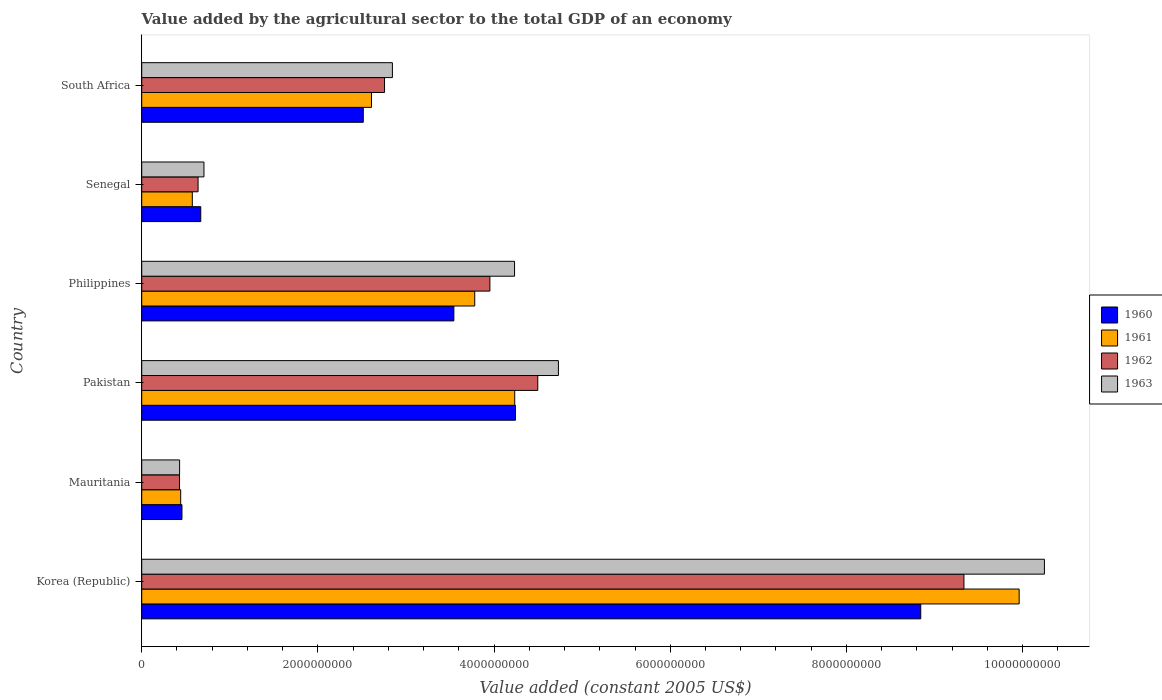Are the number of bars on each tick of the Y-axis equal?
Your response must be concise. Yes. What is the label of the 2nd group of bars from the top?
Your response must be concise. Senegal. In how many cases, is the number of bars for a given country not equal to the number of legend labels?
Keep it short and to the point. 0. What is the value added by the agricultural sector in 1960 in Pakistan?
Keep it short and to the point. 4.24e+09. Across all countries, what is the maximum value added by the agricultural sector in 1962?
Your response must be concise. 9.33e+09. Across all countries, what is the minimum value added by the agricultural sector in 1960?
Give a very brief answer. 4.57e+08. In which country was the value added by the agricultural sector in 1962 minimum?
Make the answer very short. Mauritania. What is the total value added by the agricultural sector in 1962 in the graph?
Give a very brief answer. 2.16e+1. What is the difference between the value added by the agricultural sector in 1963 in Korea (Republic) and that in Pakistan?
Give a very brief answer. 5.52e+09. What is the difference between the value added by the agricultural sector in 1960 in South Africa and the value added by the agricultural sector in 1962 in Pakistan?
Provide a short and direct response. -1.98e+09. What is the average value added by the agricultural sector in 1963 per country?
Provide a succinct answer. 3.87e+09. What is the difference between the value added by the agricultural sector in 1960 and value added by the agricultural sector in 1963 in Korea (Republic)?
Your answer should be compact. -1.40e+09. In how many countries, is the value added by the agricultural sector in 1961 greater than 400000000 US$?
Offer a terse response. 6. What is the ratio of the value added by the agricultural sector in 1961 in Korea (Republic) to that in Mauritania?
Give a very brief answer. 22.52. Is the value added by the agricultural sector in 1960 in Senegal less than that in South Africa?
Keep it short and to the point. Yes. What is the difference between the highest and the second highest value added by the agricultural sector in 1963?
Keep it short and to the point. 5.52e+09. What is the difference between the highest and the lowest value added by the agricultural sector in 1963?
Keep it short and to the point. 9.82e+09. In how many countries, is the value added by the agricultural sector in 1962 greater than the average value added by the agricultural sector in 1962 taken over all countries?
Offer a very short reply. 3. Is the sum of the value added by the agricultural sector in 1961 in Mauritania and South Africa greater than the maximum value added by the agricultural sector in 1963 across all countries?
Your answer should be compact. No. What does the 3rd bar from the top in South Africa represents?
Ensure brevity in your answer.  1961. Are the values on the major ticks of X-axis written in scientific E-notation?
Offer a terse response. No. Does the graph contain grids?
Your response must be concise. No. How many legend labels are there?
Your answer should be very brief. 4. What is the title of the graph?
Your response must be concise. Value added by the agricultural sector to the total GDP of an economy. What is the label or title of the X-axis?
Your answer should be very brief. Value added (constant 2005 US$). What is the label or title of the Y-axis?
Keep it short and to the point. Country. What is the Value added (constant 2005 US$) in 1960 in Korea (Republic)?
Make the answer very short. 8.84e+09. What is the Value added (constant 2005 US$) of 1961 in Korea (Republic)?
Provide a succinct answer. 9.96e+09. What is the Value added (constant 2005 US$) of 1962 in Korea (Republic)?
Your response must be concise. 9.33e+09. What is the Value added (constant 2005 US$) of 1963 in Korea (Republic)?
Provide a short and direct response. 1.02e+1. What is the Value added (constant 2005 US$) in 1960 in Mauritania?
Ensure brevity in your answer.  4.57e+08. What is the Value added (constant 2005 US$) in 1961 in Mauritania?
Provide a short and direct response. 4.42e+08. What is the Value added (constant 2005 US$) of 1962 in Mauritania?
Your answer should be very brief. 4.29e+08. What is the Value added (constant 2005 US$) in 1963 in Mauritania?
Offer a terse response. 4.30e+08. What is the Value added (constant 2005 US$) of 1960 in Pakistan?
Provide a succinct answer. 4.24e+09. What is the Value added (constant 2005 US$) in 1961 in Pakistan?
Ensure brevity in your answer.  4.23e+09. What is the Value added (constant 2005 US$) of 1962 in Pakistan?
Your answer should be very brief. 4.50e+09. What is the Value added (constant 2005 US$) of 1963 in Pakistan?
Offer a very short reply. 4.73e+09. What is the Value added (constant 2005 US$) in 1960 in Philippines?
Ensure brevity in your answer.  3.54e+09. What is the Value added (constant 2005 US$) in 1961 in Philippines?
Offer a very short reply. 3.78e+09. What is the Value added (constant 2005 US$) of 1962 in Philippines?
Your answer should be compact. 3.95e+09. What is the Value added (constant 2005 US$) of 1963 in Philippines?
Your answer should be very brief. 4.23e+09. What is the Value added (constant 2005 US$) of 1960 in Senegal?
Ensure brevity in your answer.  6.70e+08. What is the Value added (constant 2005 US$) in 1961 in Senegal?
Your answer should be very brief. 5.74e+08. What is the Value added (constant 2005 US$) in 1962 in Senegal?
Your response must be concise. 6.40e+08. What is the Value added (constant 2005 US$) in 1963 in Senegal?
Keep it short and to the point. 7.06e+08. What is the Value added (constant 2005 US$) of 1960 in South Africa?
Your answer should be very brief. 2.52e+09. What is the Value added (constant 2005 US$) of 1961 in South Africa?
Make the answer very short. 2.61e+09. What is the Value added (constant 2005 US$) in 1962 in South Africa?
Give a very brief answer. 2.76e+09. What is the Value added (constant 2005 US$) of 1963 in South Africa?
Your answer should be compact. 2.85e+09. Across all countries, what is the maximum Value added (constant 2005 US$) in 1960?
Ensure brevity in your answer.  8.84e+09. Across all countries, what is the maximum Value added (constant 2005 US$) of 1961?
Your response must be concise. 9.96e+09. Across all countries, what is the maximum Value added (constant 2005 US$) of 1962?
Your answer should be compact. 9.33e+09. Across all countries, what is the maximum Value added (constant 2005 US$) in 1963?
Offer a very short reply. 1.02e+1. Across all countries, what is the minimum Value added (constant 2005 US$) of 1960?
Provide a short and direct response. 4.57e+08. Across all countries, what is the minimum Value added (constant 2005 US$) of 1961?
Give a very brief answer. 4.42e+08. Across all countries, what is the minimum Value added (constant 2005 US$) in 1962?
Your response must be concise. 4.29e+08. Across all countries, what is the minimum Value added (constant 2005 US$) in 1963?
Offer a very short reply. 4.30e+08. What is the total Value added (constant 2005 US$) of 1960 in the graph?
Make the answer very short. 2.03e+1. What is the total Value added (constant 2005 US$) in 1961 in the graph?
Ensure brevity in your answer.  2.16e+1. What is the total Value added (constant 2005 US$) of 1962 in the graph?
Make the answer very short. 2.16e+1. What is the total Value added (constant 2005 US$) in 1963 in the graph?
Your answer should be compact. 2.32e+1. What is the difference between the Value added (constant 2005 US$) of 1960 in Korea (Republic) and that in Mauritania?
Give a very brief answer. 8.39e+09. What is the difference between the Value added (constant 2005 US$) in 1961 in Korea (Republic) and that in Mauritania?
Make the answer very short. 9.52e+09. What is the difference between the Value added (constant 2005 US$) of 1962 in Korea (Republic) and that in Mauritania?
Make the answer very short. 8.91e+09. What is the difference between the Value added (constant 2005 US$) of 1963 in Korea (Republic) and that in Mauritania?
Make the answer very short. 9.82e+09. What is the difference between the Value added (constant 2005 US$) in 1960 in Korea (Republic) and that in Pakistan?
Provide a succinct answer. 4.60e+09. What is the difference between the Value added (constant 2005 US$) of 1961 in Korea (Republic) and that in Pakistan?
Provide a short and direct response. 5.73e+09. What is the difference between the Value added (constant 2005 US$) of 1962 in Korea (Republic) and that in Pakistan?
Your answer should be very brief. 4.84e+09. What is the difference between the Value added (constant 2005 US$) of 1963 in Korea (Republic) and that in Pakistan?
Ensure brevity in your answer.  5.52e+09. What is the difference between the Value added (constant 2005 US$) in 1960 in Korea (Republic) and that in Philippines?
Provide a succinct answer. 5.30e+09. What is the difference between the Value added (constant 2005 US$) in 1961 in Korea (Republic) and that in Philippines?
Your response must be concise. 6.18e+09. What is the difference between the Value added (constant 2005 US$) of 1962 in Korea (Republic) and that in Philippines?
Provide a succinct answer. 5.38e+09. What is the difference between the Value added (constant 2005 US$) in 1963 in Korea (Republic) and that in Philippines?
Make the answer very short. 6.02e+09. What is the difference between the Value added (constant 2005 US$) of 1960 in Korea (Republic) and that in Senegal?
Offer a terse response. 8.17e+09. What is the difference between the Value added (constant 2005 US$) of 1961 in Korea (Republic) and that in Senegal?
Make the answer very short. 9.39e+09. What is the difference between the Value added (constant 2005 US$) of 1962 in Korea (Republic) and that in Senegal?
Your response must be concise. 8.69e+09. What is the difference between the Value added (constant 2005 US$) in 1963 in Korea (Republic) and that in Senegal?
Provide a succinct answer. 9.54e+09. What is the difference between the Value added (constant 2005 US$) of 1960 in Korea (Republic) and that in South Africa?
Provide a succinct answer. 6.33e+09. What is the difference between the Value added (constant 2005 US$) in 1961 in Korea (Republic) and that in South Africa?
Your answer should be compact. 7.35e+09. What is the difference between the Value added (constant 2005 US$) in 1962 in Korea (Republic) and that in South Africa?
Your answer should be compact. 6.58e+09. What is the difference between the Value added (constant 2005 US$) of 1963 in Korea (Republic) and that in South Africa?
Your answer should be very brief. 7.40e+09. What is the difference between the Value added (constant 2005 US$) of 1960 in Mauritania and that in Pakistan?
Your answer should be very brief. -3.79e+09. What is the difference between the Value added (constant 2005 US$) of 1961 in Mauritania and that in Pakistan?
Provide a short and direct response. -3.79e+09. What is the difference between the Value added (constant 2005 US$) in 1962 in Mauritania and that in Pakistan?
Keep it short and to the point. -4.07e+09. What is the difference between the Value added (constant 2005 US$) of 1963 in Mauritania and that in Pakistan?
Ensure brevity in your answer.  -4.30e+09. What is the difference between the Value added (constant 2005 US$) of 1960 in Mauritania and that in Philippines?
Give a very brief answer. -3.09e+09. What is the difference between the Value added (constant 2005 US$) in 1961 in Mauritania and that in Philippines?
Offer a terse response. -3.34e+09. What is the difference between the Value added (constant 2005 US$) in 1962 in Mauritania and that in Philippines?
Keep it short and to the point. -3.52e+09. What is the difference between the Value added (constant 2005 US$) in 1963 in Mauritania and that in Philippines?
Offer a very short reply. -3.80e+09. What is the difference between the Value added (constant 2005 US$) of 1960 in Mauritania and that in Senegal?
Offer a very short reply. -2.14e+08. What is the difference between the Value added (constant 2005 US$) of 1961 in Mauritania and that in Senegal?
Provide a succinct answer. -1.32e+08. What is the difference between the Value added (constant 2005 US$) of 1962 in Mauritania and that in Senegal?
Offer a terse response. -2.11e+08. What is the difference between the Value added (constant 2005 US$) of 1963 in Mauritania and that in Senegal?
Make the answer very short. -2.77e+08. What is the difference between the Value added (constant 2005 US$) of 1960 in Mauritania and that in South Africa?
Make the answer very short. -2.06e+09. What is the difference between the Value added (constant 2005 US$) in 1961 in Mauritania and that in South Africa?
Your response must be concise. -2.17e+09. What is the difference between the Value added (constant 2005 US$) of 1962 in Mauritania and that in South Africa?
Keep it short and to the point. -2.33e+09. What is the difference between the Value added (constant 2005 US$) of 1963 in Mauritania and that in South Africa?
Offer a very short reply. -2.42e+09. What is the difference between the Value added (constant 2005 US$) in 1960 in Pakistan and that in Philippines?
Make the answer very short. 7.00e+08. What is the difference between the Value added (constant 2005 US$) in 1961 in Pakistan and that in Philippines?
Give a very brief answer. 4.54e+08. What is the difference between the Value added (constant 2005 US$) of 1962 in Pakistan and that in Philippines?
Your answer should be very brief. 5.44e+08. What is the difference between the Value added (constant 2005 US$) of 1963 in Pakistan and that in Philippines?
Your answer should be very brief. 4.98e+08. What is the difference between the Value added (constant 2005 US$) in 1960 in Pakistan and that in Senegal?
Offer a very short reply. 3.57e+09. What is the difference between the Value added (constant 2005 US$) of 1961 in Pakistan and that in Senegal?
Your answer should be very brief. 3.66e+09. What is the difference between the Value added (constant 2005 US$) of 1962 in Pakistan and that in Senegal?
Your response must be concise. 3.86e+09. What is the difference between the Value added (constant 2005 US$) of 1963 in Pakistan and that in Senegal?
Your answer should be compact. 4.02e+09. What is the difference between the Value added (constant 2005 US$) of 1960 in Pakistan and that in South Africa?
Offer a terse response. 1.73e+09. What is the difference between the Value added (constant 2005 US$) in 1961 in Pakistan and that in South Africa?
Provide a short and direct response. 1.63e+09. What is the difference between the Value added (constant 2005 US$) of 1962 in Pakistan and that in South Africa?
Keep it short and to the point. 1.74e+09. What is the difference between the Value added (constant 2005 US$) of 1963 in Pakistan and that in South Africa?
Offer a terse response. 1.88e+09. What is the difference between the Value added (constant 2005 US$) in 1960 in Philippines and that in Senegal?
Give a very brief answer. 2.87e+09. What is the difference between the Value added (constant 2005 US$) in 1961 in Philippines and that in Senegal?
Make the answer very short. 3.21e+09. What is the difference between the Value added (constant 2005 US$) in 1962 in Philippines and that in Senegal?
Keep it short and to the point. 3.31e+09. What is the difference between the Value added (constant 2005 US$) of 1963 in Philippines and that in Senegal?
Your answer should be compact. 3.53e+09. What is the difference between the Value added (constant 2005 US$) of 1960 in Philippines and that in South Africa?
Your answer should be compact. 1.03e+09. What is the difference between the Value added (constant 2005 US$) in 1961 in Philippines and that in South Africa?
Offer a terse response. 1.17e+09. What is the difference between the Value added (constant 2005 US$) in 1962 in Philippines and that in South Africa?
Give a very brief answer. 1.20e+09. What is the difference between the Value added (constant 2005 US$) of 1963 in Philippines and that in South Africa?
Your response must be concise. 1.39e+09. What is the difference between the Value added (constant 2005 US$) in 1960 in Senegal and that in South Africa?
Your answer should be very brief. -1.84e+09. What is the difference between the Value added (constant 2005 US$) of 1961 in Senegal and that in South Africa?
Keep it short and to the point. -2.03e+09. What is the difference between the Value added (constant 2005 US$) in 1962 in Senegal and that in South Africa?
Ensure brevity in your answer.  -2.12e+09. What is the difference between the Value added (constant 2005 US$) of 1963 in Senegal and that in South Africa?
Offer a very short reply. -2.14e+09. What is the difference between the Value added (constant 2005 US$) in 1960 in Korea (Republic) and the Value added (constant 2005 US$) in 1961 in Mauritania?
Ensure brevity in your answer.  8.40e+09. What is the difference between the Value added (constant 2005 US$) in 1960 in Korea (Republic) and the Value added (constant 2005 US$) in 1962 in Mauritania?
Provide a succinct answer. 8.41e+09. What is the difference between the Value added (constant 2005 US$) of 1960 in Korea (Republic) and the Value added (constant 2005 US$) of 1963 in Mauritania?
Your response must be concise. 8.41e+09. What is the difference between the Value added (constant 2005 US$) in 1961 in Korea (Republic) and the Value added (constant 2005 US$) in 1962 in Mauritania?
Ensure brevity in your answer.  9.53e+09. What is the difference between the Value added (constant 2005 US$) of 1961 in Korea (Republic) and the Value added (constant 2005 US$) of 1963 in Mauritania?
Give a very brief answer. 9.53e+09. What is the difference between the Value added (constant 2005 US$) in 1962 in Korea (Republic) and the Value added (constant 2005 US$) in 1963 in Mauritania?
Give a very brief answer. 8.90e+09. What is the difference between the Value added (constant 2005 US$) of 1960 in Korea (Republic) and the Value added (constant 2005 US$) of 1961 in Pakistan?
Your response must be concise. 4.61e+09. What is the difference between the Value added (constant 2005 US$) of 1960 in Korea (Republic) and the Value added (constant 2005 US$) of 1962 in Pakistan?
Ensure brevity in your answer.  4.35e+09. What is the difference between the Value added (constant 2005 US$) of 1960 in Korea (Republic) and the Value added (constant 2005 US$) of 1963 in Pakistan?
Offer a very short reply. 4.11e+09. What is the difference between the Value added (constant 2005 US$) in 1961 in Korea (Republic) and the Value added (constant 2005 US$) in 1962 in Pakistan?
Provide a succinct answer. 5.46e+09. What is the difference between the Value added (constant 2005 US$) in 1961 in Korea (Republic) and the Value added (constant 2005 US$) in 1963 in Pakistan?
Your answer should be compact. 5.23e+09. What is the difference between the Value added (constant 2005 US$) of 1962 in Korea (Republic) and the Value added (constant 2005 US$) of 1963 in Pakistan?
Ensure brevity in your answer.  4.60e+09. What is the difference between the Value added (constant 2005 US$) in 1960 in Korea (Republic) and the Value added (constant 2005 US$) in 1961 in Philippines?
Make the answer very short. 5.06e+09. What is the difference between the Value added (constant 2005 US$) in 1960 in Korea (Republic) and the Value added (constant 2005 US$) in 1962 in Philippines?
Your answer should be very brief. 4.89e+09. What is the difference between the Value added (constant 2005 US$) of 1960 in Korea (Republic) and the Value added (constant 2005 US$) of 1963 in Philippines?
Offer a very short reply. 4.61e+09. What is the difference between the Value added (constant 2005 US$) of 1961 in Korea (Republic) and the Value added (constant 2005 US$) of 1962 in Philippines?
Offer a terse response. 6.01e+09. What is the difference between the Value added (constant 2005 US$) in 1961 in Korea (Republic) and the Value added (constant 2005 US$) in 1963 in Philippines?
Your response must be concise. 5.73e+09. What is the difference between the Value added (constant 2005 US$) in 1962 in Korea (Republic) and the Value added (constant 2005 US$) in 1963 in Philippines?
Provide a succinct answer. 5.10e+09. What is the difference between the Value added (constant 2005 US$) of 1960 in Korea (Republic) and the Value added (constant 2005 US$) of 1961 in Senegal?
Your answer should be very brief. 8.27e+09. What is the difference between the Value added (constant 2005 US$) of 1960 in Korea (Republic) and the Value added (constant 2005 US$) of 1962 in Senegal?
Keep it short and to the point. 8.20e+09. What is the difference between the Value added (constant 2005 US$) of 1960 in Korea (Republic) and the Value added (constant 2005 US$) of 1963 in Senegal?
Provide a short and direct response. 8.14e+09. What is the difference between the Value added (constant 2005 US$) in 1961 in Korea (Republic) and the Value added (constant 2005 US$) in 1962 in Senegal?
Provide a short and direct response. 9.32e+09. What is the difference between the Value added (constant 2005 US$) in 1961 in Korea (Republic) and the Value added (constant 2005 US$) in 1963 in Senegal?
Your response must be concise. 9.25e+09. What is the difference between the Value added (constant 2005 US$) in 1962 in Korea (Republic) and the Value added (constant 2005 US$) in 1963 in Senegal?
Keep it short and to the point. 8.63e+09. What is the difference between the Value added (constant 2005 US$) of 1960 in Korea (Republic) and the Value added (constant 2005 US$) of 1961 in South Africa?
Provide a short and direct response. 6.24e+09. What is the difference between the Value added (constant 2005 US$) in 1960 in Korea (Republic) and the Value added (constant 2005 US$) in 1962 in South Africa?
Make the answer very short. 6.09e+09. What is the difference between the Value added (constant 2005 US$) of 1960 in Korea (Republic) and the Value added (constant 2005 US$) of 1963 in South Africa?
Keep it short and to the point. 6.00e+09. What is the difference between the Value added (constant 2005 US$) in 1961 in Korea (Republic) and the Value added (constant 2005 US$) in 1962 in South Africa?
Provide a succinct answer. 7.20e+09. What is the difference between the Value added (constant 2005 US$) in 1961 in Korea (Republic) and the Value added (constant 2005 US$) in 1963 in South Africa?
Your answer should be very brief. 7.12e+09. What is the difference between the Value added (constant 2005 US$) in 1962 in Korea (Republic) and the Value added (constant 2005 US$) in 1963 in South Africa?
Ensure brevity in your answer.  6.49e+09. What is the difference between the Value added (constant 2005 US$) of 1960 in Mauritania and the Value added (constant 2005 US$) of 1961 in Pakistan?
Offer a terse response. -3.78e+09. What is the difference between the Value added (constant 2005 US$) in 1960 in Mauritania and the Value added (constant 2005 US$) in 1962 in Pakistan?
Give a very brief answer. -4.04e+09. What is the difference between the Value added (constant 2005 US$) of 1960 in Mauritania and the Value added (constant 2005 US$) of 1963 in Pakistan?
Offer a very short reply. -4.27e+09. What is the difference between the Value added (constant 2005 US$) in 1961 in Mauritania and the Value added (constant 2005 US$) in 1962 in Pakistan?
Your answer should be very brief. -4.05e+09. What is the difference between the Value added (constant 2005 US$) of 1961 in Mauritania and the Value added (constant 2005 US$) of 1963 in Pakistan?
Offer a terse response. -4.29e+09. What is the difference between the Value added (constant 2005 US$) of 1962 in Mauritania and the Value added (constant 2005 US$) of 1963 in Pakistan?
Make the answer very short. -4.30e+09. What is the difference between the Value added (constant 2005 US$) in 1960 in Mauritania and the Value added (constant 2005 US$) in 1961 in Philippines?
Provide a succinct answer. -3.32e+09. What is the difference between the Value added (constant 2005 US$) in 1960 in Mauritania and the Value added (constant 2005 US$) in 1962 in Philippines?
Provide a succinct answer. -3.50e+09. What is the difference between the Value added (constant 2005 US$) in 1960 in Mauritania and the Value added (constant 2005 US$) in 1963 in Philippines?
Keep it short and to the point. -3.78e+09. What is the difference between the Value added (constant 2005 US$) of 1961 in Mauritania and the Value added (constant 2005 US$) of 1962 in Philippines?
Offer a terse response. -3.51e+09. What is the difference between the Value added (constant 2005 US$) of 1961 in Mauritania and the Value added (constant 2005 US$) of 1963 in Philippines?
Your answer should be compact. -3.79e+09. What is the difference between the Value added (constant 2005 US$) of 1962 in Mauritania and the Value added (constant 2005 US$) of 1963 in Philippines?
Give a very brief answer. -3.80e+09. What is the difference between the Value added (constant 2005 US$) of 1960 in Mauritania and the Value added (constant 2005 US$) of 1961 in Senegal?
Your answer should be compact. -1.18e+08. What is the difference between the Value added (constant 2005 US$) in 1960 in Mauritania and the Value added (constant 2005 US$) in 1962 in Senegal?
Provide a succinct answer. -1.83e+08. What is the difference between the Value added (constant 2005 US$) in 1960 in Mauritania and the Value added (constant 2005 US$) in 1963 in Senegal?
Your response must be concise. -2.50e+08. What is the difference between the Value added (constant 2005 US$) of 1961 in Mauritania and the Value added (constant 2005 US$) of 1962 in Senegal?
Your response must be concise. -1.97e+08. What is the difference between the Value added (constant 2005 US$) in 1961 in Mauritania and the Value added (constant 2005 US$) in 1963 in Senegal?
Ensure brevity in your answer.  -2.64e+08. What is the difference between the Value added (constant 2005 US$) of 1962 in Mauritania and the Value added (constant 2005 US$) of 1963 in Senegal?
Give a very brief answer. -2.77e+08. What is the difference between the Value added (constant 2005 US$) of 1960 in Mauritania and the Value added (constant 2005 US$) of 1961 in South Africa?
Ensure brevity in your answer.  -2.15e+09. What is the difference between the Value added (constant 2005 US$) of 1960 in Mauritania and the Value added (constant 2005 US$) of 1962 in South Africa?
Keep it short and to the point. -2.30e+09. What is the difference between the Value added (constant 2005 US$) in 1960 in Mauritania and the Value added (constant 2005 US$) in 1963 in South Africa?
Give a very brief answer. -2.39e+09. What is the difference between the Value added (constant 2005 US$) in 1961 in Mauritania and the Value added (constant 2005 US$) in 1962 in South Africa?
Provide a succinct answer. -2.31e+09. What is the difference between the Value added (constant 2005 US$) of 1961 in Mauritania and the Value added (constant 2005 US$) of 1963 in South Africa?
Offer a very short reply. -2.40e+09. What is the difference between the Value added (constant 2005 US$) of 1962 in Mauritania and the Value added (constant 2005 US$) of 1963 in South Africa?
Provide a succinct answer. -2.42e+09. What is the difference between the Value added (constant 2005 US$) of 1960 in Pakistan and the Value added (constant 2005 US$) of 1961 in Philippines?
Ensure brevity in your answer.  4.62e+08. What is the difference between the Value added (constant 2005 US$) in 1960 in Pakistan and the Value added (constant 2005 US$) in 1962 in Philippines?
Ensure brevity in your answer.  2.90e+08. What is the difference between the Value added (constant 2005 US$) in 1960 in Pakistan and the Value added (constant 2005 US$) in 1963 in Philippines?
Offer a terse response. 1.07e+07. What is the difference between the Value added (constant 2005 US$) of 1961 in Pakistan and the Value added (constant 2005 US$) of 1962 in Philippines?
Offer a very short reply. 2.82e+08. What is the difference between the Value added (constant 2005 US$) in 1961 in Pakistan and the Value added (constant 2005 US$) in 1963 in Philippines?
Ensure brevity in your answer.  2.10e+06. What is the difference between the Value added (constant 2005 US$) of 1962 in Pakistan and the Value added (constant 2005 US$) of 1963 in Philippines?
Offer a terse response. 2.64e+08. What is the difference between the Value added (constant 2005 US$) in 1960 in Pakistan and the Value added (constant 2005 US$) in 1961 in Senegal?
Offer a very short reply. 3.67e+09. What is the difference between the Value added (constant 2005 US$) in 1960 in Pakistan and the Value added (constant 2005 US$) in 1962 in Senegal?
Give a very brief answer. 3.60e+09. What is the difference between the Value added (constant 2005 US$) in 1960 in Pakistan and the Value added (constant 2005 US$) in 1963 in Senegal?
Give a very brief answer. 3.54e+09. What is the difference between the Value added (constant 2005 US$) of 1961 in Pakistan and the Value added (constant 2005 US$) of 1962 in Senegal?
Provide a short and direct response. 3.59e+09. What is the difference between the Value added (constant 2005 US$) in 1961 in Pakistan and the Value added (constant 2005 US$) in 1963 in Senegal?
Offer a terse response. 3.53e+09. What is the difference between the Value added (constant 2005 US$) of 1962 in Pakistan and the Value added (constant 2005 US$) of 1963 in Senegal?
Your answer should be compact. 3.79e+09. What is the difference between the Value added (constant 2005 US$) in 1960 in Pakistan and the Value added (constant 2005 US$) in 1961 in South Africa?
Give a very brief answer. 1.63e+09. What is the difference between the Value added (constant 2005 US$) of 1960 in Pakistan and the Value added (constant 2005 US$) of 1962 in South Africa?
Keep it short and to the point. 1.49e+09. What is the difference between the Value added (constant 2005 US$) of 1960 in Pakistan and the Value added (constant 2005 US$) of 1963 in South Africa?
Offer a terse response. 1.40e+09. What is the difference between the Value added (constant 2005 US$) in 1961 in Pakistan and the Value added (constant 2005 US$) in 1962 in South Africa?
Offer a terse response. 1.48e+09. What is the difference between the Value added (constant 2005 US$) of 1961 in Pakistan and the Value added (constant 2005 US$) of 1963 in South Africa?
Your response must be concise. 1.39e+09. What is the difference between the Value added (constant 2005 US$) in 1962 in Pakistan and the Value added (constant 2005 US$) in 1963 in South Africa?
Your response must be concise. 1.65e+09. What is the difference between the Value added (constant 2005 US$) of 1960 in Philippines and the Value added (constant 2005 US$) of 1961 in Senegal?
Your response must be concise. 2.97e+09. What is the difference between the Value added (constant 2005 US$) of 1960 in Philippines and the Value added (constant 2005 US$) of 1962 in Senegal?
Your answer should be compact. 2.90e+09. What is the difference between the Value added (constant 2005 US$) of 1960 in Philippines and the Value added (constant 2005 US$) of 1963 in Senegal?
Keep it short and to the point. 2.84e+09. What is the difference between the Value added (constant 2005 US$) of 1961 in Philippines and the Value added (constant 2005 US$) of 1962 in Senegal?
Keep it short and to the point. 3.14e+09. What is the difference between the Value added (constant 2005 US$) in 1961 in Philippines and the Value added (constant 2005 US$) in 1963 in Senegal?
Keep it short and to the point. 3.07e+09. What is the difference between the Value added (constant 2005 US$) in 1962 in Philippines and the Value added (constant 2005 US$) in 1963 in Senegal?
Keep it short and to the point. 3.25e+09. What is the difference between the Value added (constant 2005 US$) in 1960 in Philippines and the Value added (constant 2005 US$) in 1961 in South Africa?
Your answer should be very brief. 9.35e+08. What is the difference between the Value added (constant 2005 US$) of 1960 in Philippines and the Value added (constant 2005 US$) of 1962 in South Africa?
Make the answer very short. 7.87e+08. What is the difference between the Value added (constant 2005 US$) of 1960 in Philippines and the Value added (constant 2005 US$) of 1963 in South Africa?
Ensure brevity in your answer.  6.98e+08. What is the difference between the Value added (constant 2005 US$) in 1961 in Philippines and the Value added (constant 2005 US$) in 1962 in South Africa?
Provide a short and direct response. 1.02e+09. What is the difference between the Value added (constant 2005 US$) of 1961 in Philippines and the Value added (constant 2005 US$) of 1963 in South Africa?
Your answer should be compact. 9.35e+08. What is the difference between the Value added (constant 2005 US$) in 1962 in Philippines and the Value added (constant 2005 US$) in 1963 in South Africa?
Your answer should be very brief. 1.11e+09. What is the difference between the Value added (constant 2005 US$) in 1960 in Senegal and the Value added (constant 2005 US$) in 1961 in South Africa?
Provide a short and direct response. -1.94e+09. What is the difference between the Value added (constant 2005 US$) of 1960 in Senegal and the Value added (constant 2005 US$) of 1962 in South Africa?
Offer a terse response. -2.09e+09. What is the difference between the Value added (constant 2005 US$) of 1960 in Senegal and the Value added (constant 2005 US$) of 1963 in South Africa?
Give a very brief answer. -2.18e+09. What is the difference between the Value added (constant 2005 US$) in 1961 in Senegal and the Value added (constant 2005 US$) in 1962 in South Africa?
Offer a very short reply. -2.18e+09. What is the difference between the Value added (constant 2005 US$) in 1961 in Senegal and the Value added (constant 2005 US$) in 1963 in South Africa?
Offer a terse response. -2.27e+09. What is the difference between the Value added (constant 2005 US$) in 1962 in Senegal and the Value added (constant 2005 US$) in 1963 in South Africa?
Your answer should be compact. -2.21e+09. What is the average Value added (constant 2005 US$) in 1960 per country?
Provide a succinct answer. 3.38e+09. What is the average Value added (constant 2005 US$) of 1961 per country?
Your response must be concise. 3.60e+09. What is the average Value added (constant 2005 US$) of 1962 per country?
Your answer should be compact. 3.60e+09. What is the average Value added (constant 2005 US$) of 1963 per country?
Give a very brief answer. 3.87e+09. What is the difference between the Value added (constant 2005 US$) of 1960 and Value added (constant 2005 US$) of 1961 in Korea (Republic)?
Provide a short and direct response. -1.12e+09. What is the difference between the Value added (constant 2005 US$) of 1960 and Value added (constant 2005 US$) of 1962 in Korea (Republic)?
Keep it short and to the point. -4.90e+08. What is the difference between the Value added (constant 2005 US$) of 1960 and Value added (constant 2005 US$) of 1963 in Korea (Republic)?
Your answer should be very brief. -1.40e+09. What is the difference between the Value added (constant 2005 US$) in 1961 and Value added (constant 2005 US$) in 1962 in Korea (Republic)?
Provide a short and direct response. 6.27e+08. What is the difference between the Value added (constant 2005 US$) of 1961 and Value added (constant 2005 US$) of 1963 in Korea (Republic)?
Give a very brief answer. -2.87e+08. What is the difference between the Value added (constant 2005 US$) of 1962 and Value added (constant 2005 US$) of 1963 in Korea (Republic)?
Ensure brevity in your answer.  -9.14e+08. What is the difference between the Value added (constant 2005 US$) of 1960 and Value added (constant 2005 US$) of 1961 in Mauritania?
Offer a very short reply. 1.44e+07. What is the difference between the Value added (constant 2005 US$) in 1960 and Value added (constant 2005 US$) in 1962 in Mauritania?
Ensure brevity in your answer.  2.75e+07. What is the difference between the Value added (constant 2005 US$) in 1960 and Value added (constant 2005 US$) in 1963 in Mauritania?
Your answer should be compact. 2.68e+07. What is the difference between the Value added (constant 2005 US$) of 1961 and Value added (constant 2005 US$) of 1962 in Mauritania?
Provide a succinct answer. 1.31e+07. What is the difference between the Value added (constant 2005 US$) of 1961 and Value added (constant 2005 US$) of 1963 in Mauritania?
Ensure brevity in your answer.  1.24e+07. What is the difference between the Value added (constant 2005 US$) in 1962 and Value added (constant 2005 US$) in 1963 in Mauritania?
Offer a terse response. -7.06e+05. What is the difference between the Value added (constant 2005 US$) in 1960 and Value added (constant 2005 US$) in 1961 in Pakistan?
Make the answer very short. 8.56e+06. What is the difference between the Value added (constant 2005 US$) in 1960 and Value added (constant 2005 US$) in 1962 in Pakistan?
Your answer should be compact. -2.53e+08. What is the difference between the Value added (constant 2005 US$) of 1960 and Value added (constant 2005 US$) of 1963 in Pakistan?
Offer a very short reply. -4.87e+08. What is the difference between the Value added (constant 2005 US$) in 1961 and Value added (constant 2005 US$) in 1962 in Pakistan?
Give a very brief answer. -2.62e+08. What is the difference between the Value added (constant 2005 US$) of 1961 and Value added (constant 2005 US$) of 1963 in Pakistan?
Your answer should be very brief. -4.96e+08. What is the difference between the Value added (constant 2005 US$) of 1962 and Value added (constant 2005 US$) of 1963 in Pakistan?
Provide a short and direct response. -2.34e+08. What is the difference between the Value added (constant 2005 US$) of 1960 and Value added (constant 2005 US$) of 1961 in Philippines?
Your answer should be compact. -2.37e+08. What is the difference between the Value added (constant 2005 US$) of 1960 and Value added (constant 2005 US$) of 1962 in Philippines?
Offer a terse response. -4.09e+08. What is the difference between the Value added (constant 2005 US$) of 1960 and Value added (constant 2005 US$) of 1963 in Philippines?
Your response must be concise. -6.89e+08. What is the difference between the Value added (constant 2005 US$) in 1961 and Value added (constant 2005 US$) in 1962 in Philippines?
Give a very brief answer. -1.72e+08. What is the difference between the Value added (constant 2005 US$) of 1961 and Value added (constant 2005 US$) of 1963 in Philippines?
Your answer should be very brief. -4.52e+08. What is the difference between the Value added (constant 2005 US$) in 1962 and Value added (constant 2005 US$) in 1963 in Philippines?
Your response must be concise. -2.80e+08. What is the difference between the Value added (constant 2005 US$) of 1960 and Value added (constant 2005 US$) of 1961 in Senegal?
Keep it short and to the point. 9.60e+07. What is the difference between the Value added (constant 2005 US$) of 1960 and Value added (constant 2005 US$) of 1962 in Senegal?
Your answer should be very brief. 3.06e+07. What is the difference between the Value added (constant 2005 US$) in 1960 and Value added (constant 2005 US$) in 1963 in Senegal?
Offer a very short reply. -3.60e+07. What is the difference between the Value added (constant 2005 US$) in 1961 and Value added (constant 2005 US$) in 1962 in Senegal?
Your answer should be very brief. -6.53e+07. What is the difference between the Value added (constant 2005 US$) of 1961 and Value added (constant 2005 US$) of 1963 in Senegal?
Your answer should be very brief. -1.32e+08. What is the difference between the Value added (constant 2005 US$) of 1962 and Value added (constant 2005 US$) of 1963 in Senegal?
Provide a succinct answer. -6.67e+07. What is the difference between the Value added (constant 2005 US$) of 1960 and Value added (constant 2005 US$) of 1961 in South Africa?
Give a very brief answer. -9.34e+07. What is the difference between the Value added (constant 2005 US$) in 1960 and Value added (constant 2005 US$) in 1962 in South Africa?
Provide a succinct answer. -2.41e+08. What is the difference between the Value added (constant 2005 US$) of 1960 and Value added (constant 2005 US$) of 1963 in South Africa?
Offer a very short reply. -3.31e+08. What is the difference between the Value added (constant 2005 US$) of 1961 and Value added (constant 2005 US$) of 1962 in South Africa?
Make the answer very short. -1.48e+08. What is the difference between the Value added (constant 2005 US$) of 1961 and Value added (constant 2005 US$) of 1963 in South Africa?
Your response must be concise. -2.37e+08. What is the difference between the Value added (constant 2005 US$) in 1962 and Value added (constant 2005 US$) in 1963 in South Africa?
Provide a succinct answer. -8.93e+07. What is the ratio of the Value added (constant 2005 US$) of 1960 in Korea (Republic) to that in Mauritania?
Give a very brief answer. 19.37. What is the ratio of the Value added (constant 2005 US$) of 1961 in Korea (Republic) to that in Mauritania?
Keep it short and to the point. 22.52. What is the ratio of the Value added (constant 2005 US$) in 1962 in Korea (Republic) to that in Mauritania?
Provide a short and direct response. 21.75. What is the ratio of the Value added (constant 2005 US$) of 1963 in Korea (Republic) to that in Mauritania?
Offer a very short reply. 23.84. What is the ratio of the Value added (constant 2005 US$) of 1960 in Korea (Republic) to that in Pakistan?
Provide a short and direct response. 2.08. What is the ratio of the Value added (constant 2005 US$) of 1961 in Korea (Republic) to that in Pakistan?
Your answer should be very brief. 2.35. What is the ratio of the Value added (constant 2005 US$) in 1962 in Korea (Republic) to that in Pakistan?
Give a very brief answer. 2.08. What is the ratio of the Value added (constant 2005 US$) of 1963 in Korea (Republic) to that in Pakistan?
Offer a terse response. 2.17. What is the ratio of the Value added (constant 2005 US$) of 1960 in Korea (Republic) to that in Philippines?
Your response must be concise. 2.5. What is the ratio of the Value added (constant 2005 US$) of 1961 in Korea (Republic) to that in Philippines?
Give a very brief answer. 2.63. What is the ratio of the Value added (constant 2005 US$) of 1962 in Korea (Republic) to that in Philippines?
Provide a succinct answer. 2.36. What is the ratio of the Value added (constant 2005 US$) of 1963 in Korea (Republic) to that in Philippines?
Offer a terse response. 2.42. What is the ratio of the Value added (constant 2005 US$) of 1960 in Korea (Republic) to that in Senegal?
Ensure brevity in your answer.  13.19. What is the ratio of the Value added (constant 2005 US$) in 1961 in Korea (Republic) to that in Senegal?
Your answer should be very brief. 17.34. What is the ratio of the Value added (constant 2005 US$) in 1962 in Korea (Republic) to that in Senegal?
Provide a succinct answer. 14.59. What is the ratio of the Value added (constant 2005 US$) in 1963 in Korea (Republic) to that in Senegal?
Your answer should be very brief. 14.51. What is the ratio of the Value added (constant 2005 US$) of 1960 in Korea (Republic) to that in South Africa?
Ensure brevity in your answer.  3.52. What is the ratio of the Value added (constant 2005 US$) in 1961 in Korea (Republic) to that in South Africa?
Provide a succinct answer. 3.82. What is the ratio of the Value added (constant 2005 US$) in 1962 in Korea (Republic) to that in South Africa?
Ensure brevity in your answer.  3.39. What is the ratio of the Value added (constant 2005 US$) in 1963 in Korea (Republic) to that in South Africa?
Your response must be concise. 3.6. What is the ratio of the Value added (constant 2005 US$) of 1960 in Mauritania to that in Pakistan?
Provide a succinct answer. 0.11. What is the ratio of the Value added (constant 2005 US$) of 1961 in Mauritania to that in Pakistan?
Ensure brevity in your answer.  0.1. What is the ratio of the Value added (constant 2005 US$) of 1962 in Mauritania to that in Pakistan?
Your response must be concise. 0.1. What is the ratio of the Value added (constant 2005 US$) of 1963 in Mauritania to that in Pakistan?
Your response must be concise. 0.09. What is the ratio of the Value added (constant 2005 US$) of 1960 in Mauritania to that in Philippines?
Make the answer very short. 0.13. What is the ratio of the Value added (constant 2005 US$) in 1961 in Mauritania to that in Philippines?
Ensure brevity in your answer.  0.12. What is the ratio of the Value added (constant 2005 US$) of 1962 in Mauritania to that in Philippines?
Keep it short and to the point. 0.11. What is the ratio of the Value added (constant 2005 US$) in 1963 in Mauritania to that in Philippines?
Offer a terse response. 0.1. What is the ratio of the Value added (constant 2005 US$) of 1960 in Mauritania to that in Senegal?
Your answer should be compact. 0.68. What is the ratio of the Value added (constant 2005 US$) of 1961 in Mauritania to that in Senegal?
Offer a very short reply. 0.77. What is the ratio of the Value added (constant 2005 US$) of 1962 in Mauritania to that in Senegal?
Keep it short and to the point. 0.67. What is the ratio of the Value added (constant 2005 US$) of 1963 in Mauritania to that in Senegal?
Provide a short and direct response. 0.61. What is the ratio of the Value added (constant 2005 US$) of 1960 in Mauritania to that in South Africa?
Offer a very short reply. 0.18. What is the ratio of the Value added (constant 2005 US$) of 1961 in Mauritania to that in South Africa?
Offer a very short reply. 0.17. What is the ratio of the Value added (constant 2005 US$) of 1962 in Mauritania to that in South Africa?
Give a very brief answer. 0.16. What is the ratio of the Value added (constant 2005 US$) in 1963 in Mauritania to that in South Africa?
Make the answer very short. 0.15. What is the ratio of the Value added (constant 2005 US$) in 1960 in Pakistan to that in Philippines?
Your answer should be very brief. 1.2. What is the ratio of the Value added (constant 2005 US$) in 1961 in Pakistan to that in Philippines?
Provide a short and direct response. 1.12. What is the ratio of the Value added (constant 2005 US$) of 1962 in Pakistan to that in Philippines?
Make the answer very short. 1.14. What is the ratio of the Value added (constant 2005 US$) in 1963 in Pakistan to that in Philippines?
Give a very brief answer. 1.12. What is the ratio of the Value added (constant 2005 US$) of 1960 in Pakistan to that in Senegal?
Provide a short and direct response. 6.33. What is the ratio of the Value added (constant 2005 US$) of 1961 in Pakistan to that in Senegal?
Your answer should be compact. 7.37. What is the ratio of the Value added (constant 2005 US$) in 1962 in Pakistan to that in Senegal?
Your response must be concise. 7.03. What is the ratio of the Value added (constant 2005 US$) in 1963 in Pakistan to that in Senegal?
Ensure brevity in your answer.  6.7. What is the ratio of the Value added (constant 2005 US$) of 1960 in Pakistan to that in South Africa?
Make the answer very short. 1.69. What is the ratio of the Value added (constant 2005 US$) of 1961 in Pakistan to that in South Africa?
Give a very brief answer. 1.62. What is the ratio of the Value added (constant 2005 US$) in 1962 in Pakistan to that in South Africa?
Keep it short and to the point. 1.63. What is the ratio of the Value added (constant 2005 US$) of 1963 in Pakistan to that in South Africa?
Provide a short and direct response. 1.66. What is the ratio of the Value added (constant 2005 US$) in 1960 in Philippines to that in Senegal?
Offer a very short reply. 5.29. What is the ratio of the Value added (constant 2005 US$) of 1961 in Philippines to that in Senegal?
Offer a very short reply. 6.58. What is the ratio of the Value added (constant 2005 US$) in 1962 in Philippines to that in Senegal?
Your answer should be very brief. 6.18. What is the ratio of the Value added (constant 2005 US$) in 1963 in Philippines to that in Senegal?
Your answer should be compact. 5.99. What is the ratio of the Value added (constant 2005 US$) of 1960 in Philippines to that in South Africa?
Your response must be concise. 1.41. What is the ratio of the Value added (constant 2005 US$) of 1961 in Philippines to that in South Africa?
Provide a succinct answer. 1.45. What is the ratio of the Value added (constant 2005 US$) in 1962 in Philippines to that in South Africa?
Make the answer very short. 1.43. What is the ratio of the Value added (constant 2005 US$) of 1963 in Philippines to that in South Africa?
Your answer should be very brief. 1.49. What is the ratio of the Value added (constant 2005 US$) of 1960 in Senegal to that in South Africa?
Your answer should be very brief. 0.27. What is the ratio of the Value added (constant 2005 US$) of 1961 in Senegal to that in South Africa?
Offer a terse response. 0.22. What is the ratio of the Value added (constant 2005 US$) in 1962 in Senegal to that in South Africa?
Provide a succinct answer. 0.23. What is the ratio of the Value added (constant 2005 US$) in 1963 in Senegal to that in South Africa?
Provide a succinct answer. 0.25. What is the difference between the highest and the second highest Value added (constant 2005 US$) of 1960?
Provide a succinct answer. 4.60e+09. What is the difference between the highest and the second highest Value added (constant 2005 US$) in 1961?
Make the answer very short. 5.73e+09. What is the difference between the highest and the second highest Value added (constant 2005 US$) in 1962?
Keep it short and to the point. 4.84e+09. What is the difference between the highest and the second highest Value added (constant 2005 US$) in 1963?
Your answer should be compact. 5.52e+09. What is the difference between the highest and the lowest Value added (constant 2005 US$) in 1960?
Ensure brevity in your answer.  8.39e+09. What is the difference between the highest and the lowest Value added (constant 2005 US$) of 1961?
Offer a terse response. 9.52e+09. What is the difference between the highest and the lowest Value added (constant 2005 US$) in 1962?
Provide a short and direct response. 8.91e+09. What is the difference between the highest and the lowest Value added (constant 2005 US$) in 1963?
Offer a terse response. 9.82e+09. 